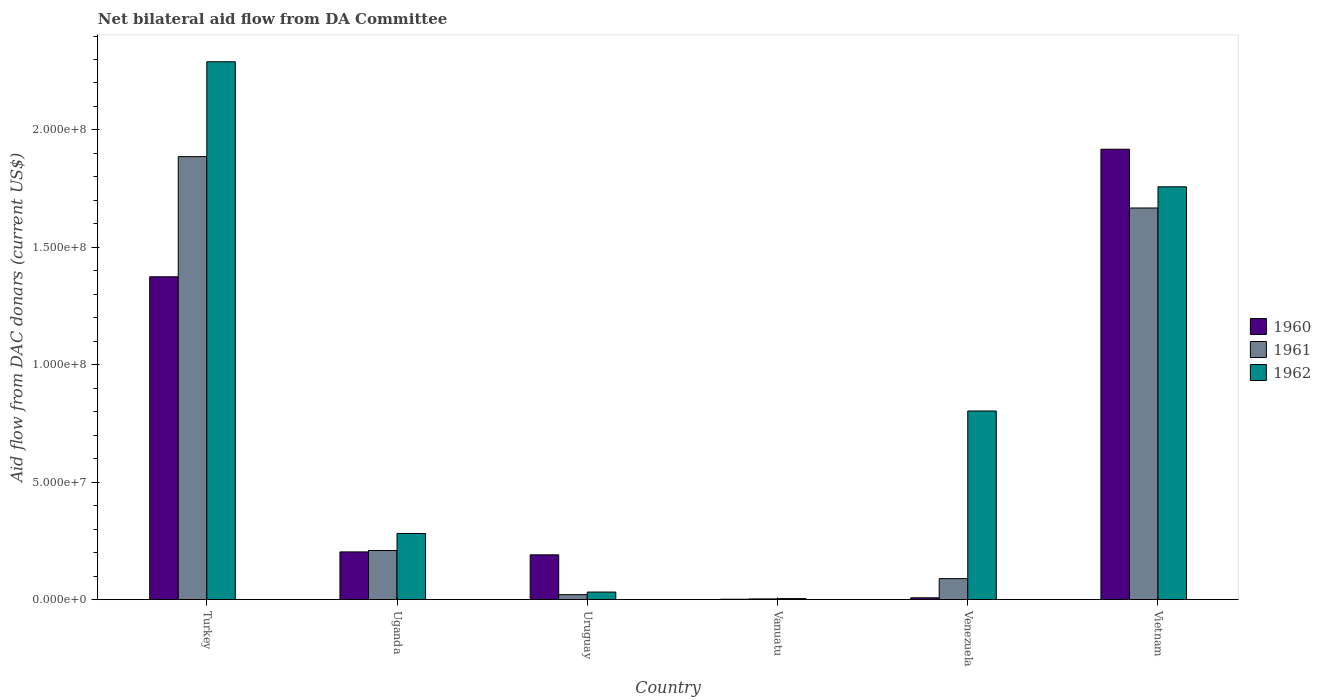How many different coloured bars are there?
Keep it short and to the point. 3. How many groups of bars are there?
Provide a short and direct response. 6. Are the number of bars on each tick of the X-axis equal?
Provide a short and direct response. Yes. How many bars are there on the 2nd tick from the right?
Your response must be concise. 3. What is the label of the 4th group of bars from the left?
Provide a short and direct response. Vanuatu. In how many cases, is the number of bars for a given country not equal to the number of legend labels?
Your answer should be compact. 0. What is the aid flow in in 1960 in Turkey?
Your answer should be very brief. 1.37e+08. Across all countries, what is the maximum aid flow in in 1960?
Give a very brief answer. 1.92e+08. Across all countries, what is the minimum aid flow in in 1960?
Offer a very short reply. 1.50e+05. In which country was the aid flow in in 1962 maximum?
Offer a terse response. Turkey. In which country was the aid flow in in 1962 minimum?
Give a very brief answer. Vanuatu. What is the total aid flow in in 1962 in the graph?
Ensure brevity in your answer.  5.17e+08. What is the difference between the aid flow in in 1961 in Turkey and that in Vanuatu?
Keep it short and to the point. 1.88e+08. What is the difference between the aid flow in in 1962 in Vietnam and the aid flow in in 1961 in Turkey?
Give a very brief answer. -1.28e+07. What is the average aid flow in in 1962 per country?
Offer a terse response. 8.61e+07. What is the difference between the aid flow in of/in 1962 and aid flow in of/in 1961 in Vietnam?
Your response must be concise. 9.02e+06. What is the ratio of the aid flow in in 1960 in Uruguay to that in Vietnam?
Your answer should be compact. 0.1. Is the aid flow in in 1962 in Turkey less than that in Uganda?
Offer a very short reply. No. Is the difference between the aid flow in in 1962 in Turkey and Vanuatu greater than the difference between the aid flow in in 1961 in Turkey and Vanuatu?
Give a very brief answer. Yes. What is the difference between the highest and the second highest aid flow in in 1961?
Provide a short and direct response. 2.19e+07. What is the difference between the highest and the lowest aid flow in in 1960?
Provide a succinct answer. 1.92e+08. What does the 2nd bar from the left in Venezuela represents?
Ensure brevity in your answer.  1961. Are all the bars in the graph horizontal?
Offer a terse response. No. How many countries are there in the graph?
Give a very brief answer. 6. Are the values on the major ticks of Y-axis written in scientific E-notation?
Your answer should be compact. Yes. How many legend labels are there?
Ensure brevity in your answer.  3. What is the title of the graph?
Give a very brief answer. Net bilateral aid flow from DA Committee. Does "2013" appear as one of the legend labels in the graph?
Offer a very short reply. No. What is the label or title of the X-axis?
Your response must be concise. Country. What is the label or title of the Y-axis?
Your answer should be very brief. Aid flow from DAC donars (current US$). What is the Aid flow from DAC donars (current US$) of 1960 in Turkey?
Make the answer very short. 1.37e+08. What is the Aid flow from DAC donars (current US$) of 1961 in Turkey?
Your response must be concise. 1.89e+08. What is the Aid flow from DAC donars (current US$) of 1962 in Turkey?
Provide a succinct answer. 2.29e+08. What is the Aid flow from DAC donars (current US$) of 1960 in Uganda?
Make the answer very short. 2.03e+07. What is the Aid flow from DAC donars (current US$) in 1961 in Uganda?
Provide a short and direct response. 2.09e+07. What is the Aid flow from DAC donars (current US$) of 1962 in Uganda?
Your answer should be very brief. 2.82e+07. What is the Aid flow from DAC donars (current US$) in 1960 in Uruguay?
Provide a succinct answer. 1.90e+07. What is the Aid flow from DAC donars (current US$) of 1961 in Uruguay?
Your answer should be very brief. 2.09e+06. What is the Aid flow from DAC donars (current US$) of 1962 in Uruguay?
Make the answer very short. 3.20e+06. What is the Aid flow from DAC donars (current US$) in 1961 in Vanuatu?
Keep it short and to the point. 2.80e+05. What is the Aid flow from DAC donars (current US$) in 1960 in Venezuela?
Your answer should be compact. 7.60e+05. What is the Aid flow from DAC donars (current US$) in 1961 in Venezuela?
Offer a terse response. 8.92e+06. What is the Aid flow from DAC donars (current US$) of 1962 in Venezuela?
Offer a very short reply. 8.03e+07. What is the Aid flow from DAC donars (current US$) in 1960 in Vietnam?
Give a very brief answer. 1.92e+08. What is the Aid flow from DAC donars (current US$) in 1961 in Vietnam?
Your answer should be compact. 1.67e+08. What is the Aid flow from DAC donars (current US$) of 1962 in Vietnam?
Provide a short and direct response. 1.76e+08. Across all countries, what is the maximum Aid flow from DAC donars (current US$) in 1960?
Your answer should be very brief. 1.92e+08. Across all countries, what is the maximum Aid flow from DAC donars (current US$) of 1961?
Provide a short and direct response. 1.89e+08. Across all countries, what is the maximum Aid flow from DAC donars (current US$) in 1962?
Your response must be concise. 2.29e+08. What is the total Aid flow from DAC donars (current US$) in 1960 in the graph?
Your answer should be compact. 3.70e+08. What is the total Aid flow from DAC donars (current US$) of 1961 in the graph?
Ensure brevity in your answer.  3.88e+08. What is the total Aid flow from DAC donars (current US$) in 1962 in the graph?
Make the answer very short. 5.17e+08. What is the difference between the Aid flow from DAC donars (current US$) of 1960 in Turkey and that in Uganda?
Your answer should be very brief. 1.17e+08. What is the difference between the Aid flow from DAC donars (current US$) of 1961 in Turkey and that in Uganda?
Your response must be concise. 1.68e+08. What is the difference between the Aid flow from DAC donars (current US$) of 1962 in Turkey and that in Uganda?
Your answer should be compact. 2.01e+08. What is the difference between the Aid flow from DAC donars (current US$) in 1960 in Turkey and that in Uruguay?
Make the answer very short. 1.18e+08. What is the difference between the Aid flow from DAC donars (current US$) of 1961 in Turkey and that in Uruguay?
Offer a very short reply. 1.87e+08. What is the difference between the Aid flow from DAC donars (current US$) in 1962 in Turkey and that in Uruguay?
Ensure brevity in your answer.  2.26e+08. What is the difference between the Aid flow from DAC donars (current US$) in 1960 in Turkey and that in Vanuatu?
Make the answer very short. 1.37e+08. What is the difference between the Aid flow from DAC donars (current US$) of 1961 in Turkey and that in Vanuatu?
Your response must be concise. 1.88e+08. What is the difference between the Aid flow from DAC donars (current US$) in 1962 in Turkey and that in Vanuatu?
Ensure brevity in your answer.  2.29e+08. What is the difference between the Aid flow from DAC donars (current US$) of 1960 in Turkey and that in Venezuela?
Ensure brevity in your answer.  1.37e+08. What is the difference between the Aid flow from DAC donars (current US$) of 1961 in Turkey and that in Venezuela?
Provide a short and direct response. 1.80e+08. What is the difference between the Aid flow from DAC donars (current US$) in 1962 in Turkey and that in Venezuela?
Your answer should be very brief. 1.49e+08. What is the difference between the Aid flow from DAC donars (current US$) in 1960 in Turkey and that in Vietnam?
Keep it short and to the point. -5.43e+07. What is the difference between the Aid flow from DAC donars (current US$) in 1961 in Turkey and that in Vietnam?
Provide a succinct answer. 2.19e+07. What is the difference between the Aid flow from DAC donars (current US$) in 1962 in Turkey and that in Vietnam?
Your answer should be compact. 5.32e+07. What is the difference between the Aid flow from DAC donars (current US$) of 1960 in Uganda and that in Uruguay?
Your answer should be very brief. 1.25e+06. What is the difference between the Aid flow from DAC donars (current US$) of 1961 in Uganda and that in Uruguay?
Keep it short and to the point. 1.88e+07. What is the difference between the Aid flow from DAC donars (current US$) in 1962 in Uganda and that in Uruguay?
Make the answer very short. 2.50e+07. What is the difference between the Aid flow from DAC donars (current US$) in 1960 in Uganda and that in Vanuatu?
Offer a very short reply. 2.02e+07. What is the difference between the Aid flow from DAC donars (current US$) of 1961 in Uganda and that in Vanuatu?
Give a very brief answer. 2.06e+07. What is the difference between the Aid flow from DAC donars (current US$) of 1962 in Uganda and that in Vanuatu?
Make the answer very short. 2.77e+07. What is the difference between the Aid flow from DAC donars (current US$) of 1960 in Uganda and that in Venezuela?
Give a very brief answer. 1.95e+07. What is the difference between the Aid flow from DAC donars (current US$) of 1961 in Uganda and that in Venezuela?
Keep it short and to the point. 1.20e+07. What is the difference between the Aid flow from DAC donars (current US$) of 1962 in Uganda and that in Venezuela?
Provide a succinct answer. -5.22e+07. What is the difference between the Aid flow from DAC donars (current US$) of 1960 in Uganda and that in Vietnam?
Offer a terse response. -1.71e+08. What is the difference between the Aid flow from DAC donars (current US$) of 1961 in Uganda and that in Vietnam?
Offer a very short reply. -1.46e+08. What is the difference between the Aid flow from DAC donars (current US$) of 1962 in Uganda and that in Vietnam?
Provide a short and direct response. -1.48e+08. What is the difference between the Aid flow from DAC donars (current US$) in 1960 in Uruguay and that in Vanuatu?
Make the answer very short. 1.89e+07. What is the difference between the Aid flow from DAC donars (current US$) in 1961 in Uruguay and that in Vanuatu?
Your answer should be compact. 1.81e+06. What is the difference between the Aid flow from DAC donars (current US$) in 1962 in Uruguay and that in Vanuatu?
Offer a terse response. 2.79e+06. What is the difference between the Aid flow from DAC donars (current US$) of 1960 in Uruguay and that in Venezuela?
Offer a terse response. 1.83e+07. What is the difference between the Aid flow from DAC donars (current US$) of 1961 in Uruguay and that in Venezuela?
Keep it short and to the point. -6.83e+06. What is the difference between the Aid flow from DAC donars (current US$) in 1962 in Uruguay and that in Venezuela?
Make the answer very short. -7.71e+07. What is the difference between the Aid flow from DAC donars (current US$) in 1960 in Uruguay and that in Vietnam?
Provide a short and direct response. -1.73e+08. What is the difference between the Aid flow from DAC donars (current US$) in 1961 in Uruguay and that in Vietnam?
Provide a short and direct response. -1.65e+08. What is the difference between the Aid flow from DAC donars (current US$) of 1962 in Uruguay and that in Vietnam?
Ensure brevity in your answer.  -1.73e+08. What is the difference between the Aid flow from DAC donars (current US$) of 1960 in Vanuatu and that in Venezuela?
Your answer should be very brief. -6.10e+05. What is the difference between the Aid flow from DAC donars (current US$) in 1961 in Vanuatu and that in Venezuela?
Your answer should be very brief. -8.64e+06. What is the difference between the Aid flow from DAC donars (current US$) in 1962 in Vanuatu and that in Venezuela?
Keep it short and to the point. -7.99e+07. What is the difference between the Aid flow from DAC donars (current US$) of 1960 in Vanuatu and that in Vietnam?
Provide a short and direct response. -1.92e+08. What is the difference between the Aid flow from DAC donars (current US$) in 1961 in Vanuatu and that in Vietnam?
Offer a very short reply. -1.66e+08. What is the difference between the Aid flow from DAC donars (current US$) in 1962 in Vanuatu and that in Vietnam?
Give a very brief answer. -1.75e+08. What is the difference between the Aid flow from DAC donars (current US$) of 1960 in Venezuela and that in Vietnam?
Offer a very short reply. -1.91e+08. What is the difference between the Aid flow from DAC donars (current US$) in 1961 in Venezuela and that in Vietnam?
Keep it short and to the point. -1.58e+08. What is the difference between the Aid flow from DAC donars (current US$) in 1962 in Venezuela and that in Vietnam?
Provide a succinct answer. -9.55e+07. What is the difference between the Aid flow from DAC donars (current US$) in 1960 in Turkey and the Aid flow from DAC donars (current US$) in 1961 in Uganda?
Provide a short and direct response. 1.17e+08. What is the difference between the Aid flow from DAC donars (current US$) in 1960 in Turkey and the Aid flow from DAC donars (current US$) in 1962 in Uganda?
Provide a short and direct response. 1.09e+08. What is the difference between the Aid flow from DAC donars (current US$) of 1961 in Turkey and the Aid flow from DAC donars (current US$) of 1962 in Uganda?
Your answer should be very brief. 1.60e+08. What is the difference between the Aid flow from DAC donars (current US$) of 1960 in Turkey and the Aid flow from DAC donars (current US$) of 1961 in Uruguay?
Keep it short and to the point. 1.35e+08. What is the difference between the Aid flow from DAC donars (current US$) of 1960 in Turkey and the Aid flow from DAC donars (current US$) of 1962 in Uruguay?
Your answer should be very brief. 1.34e+08. What is the difference between the Aid flow from DAC donars (current US$) of 1961 in Turkey and the Aid flow from DAC donars (current US$) of 1962 in Uruguay?
Make the answer very short. 1.85e+08. What is the difference between the Aid flow from DAC donars (current US$) in 1960 in Turkey and the Aid flow from DAC donars (current US$) in 1961 in Vanuatu?
Provide a succinct answer. 1.37e+08. What is the difference between the Aid flow from DAC donars (current US$) of 1960 in Turkey and the Aid flow from DAC donars (current US$) of 1962 in Vanuatu?
Provide a succinct answer. 1.37e+08. What is the difference between the Aid flow from DAC donars (current US$) in 1961 in Turkey and the Aid flow from DAC donars (current US$) in 1962 in Vanuatu?
Provide a short and direct response. 1.88e+08. What is the difference between the Aid flow from DAC donars (current US$) in 1960 in Turkey and the Aid flow from DAC donars (current US$) in 1961 in Venezuela?
Ensure brevity in your answer.  1.29e+08. What is the difference between the Aid flow from DAC donars (current US$) of 1960 in Turkey and the Aid flow from DAC donars (current US$) of 1962 in Venezuela?
Offer a very short reply. 5.72e+07. What is the difference between the Aid flow from DAC donars (current US$) in 1961 in Turkey and the Aid flow from DAC donars (current US$) in 1962 in Venezuela?
Give a very brief answer. 1.08e+08. What is the difference between the Aid flow from DAC donars (current US$) of 1960 in Turkey and the Aid flow from DAC donars (current US$) of 1961 in Vietnam?
Your answer should be very brief. -2.93e+07. What is the difference between the Aid flow from DAC donars (current US$) of 1960 in Turkey and the Aid flow from DAC donars (current US$) of 1962 in Vietnam?
Your answer should be compact. -3.83e+07. What is the difference between the Aid flow from DAC donars (current US$) in 1961 in Turkey and the Aid flow from DAC donars (current US$) in 1962 in Vietnam?
Your answer should be compact. 1.28e+07. What is the difference between the Aid flow from DAC donars (current US$) of 1960 in Uganda and the Aid flow from DAC donars (current US$) of 1961 in Uruguay?
Provide a succinct answer. 1.82e+07. What is the difference between the Aid flow from DAC donars (current US$) in 1960 in Uganda and the Aid flow from DAC donars (current US$) in 1962 in Uruguay?
Keep it short and to the point. 1.71e+07. What is the difference between the Aid flow from DAC donars (current US$) of 1961 in Uganda and the Aid flow from DAC donars (current US$) of 1962 in Uruguay?
Provide a succinct answer. 1.77e+07. What is the difference between the Aid flow from DAC donars (current US$) in 1960 in Uganda and the Aid flow from DAC donars (current US$) in 1961 in Vanuatu?
Give a very brief answer. 2.00e+07. What is the difference between the Aid flow from DAC donars (current US$) of 1960 in Uganda and the Aid flow from DAC donars (current US$) of 1962 in Vanuatu?
Offer a terse response. 1.99e+07. What is the difference between the Aid flow from DAC donars (current US$) of 1961 in Uganda and the Aid flow from DAC donars (current US$) of 1962 in Vanuatu?
Provide a short and direct response. 2.05e+07. What is the difference between the Aid flow from DAC donars (current US$) in 1960 in Uganda and the Aid flow from DAC donars (current US$) in 1961 in Venezuela?
Ensure brevity in your answer.  1.14e+07. What is the difference between the Aid flow from DAC donars (current US$) of 1960 in Uganda and the Aid flow from DAC donars (current US$) of 1962 in Venezuela?
Keep it short and to the point. -6.00e+07. What is the difference between the Aid flow from DAC donars (current US$) in 1961 in Uganda and the Aid flow from DAC donars (current US$) in 1962 in Venezuela?
Provide a short and direct response. -5.94e+07. What is the difference between the Aid flow from DAC donars (current US$) in 1960 in Uganda and the Aid flow from DAC donars (current US$) in 1961 in Vietnam?
Your answer should be very brief. -1.46e+08. What is the difference between the Aid flow from DAC donars (current US$) in 1960 in Uganda and the Aid flow from DAC donars (current US$) in 1962 in Vietnam?
Your response must be concise. -1.55e+08. What is the difference between the Aid flow from DAC donars (current US$) in 1961 in Uganda and the Aid flow from DAC donars (current US$) in 1962 in Vietnam?
Your answer should be very brief. -1.55e+08. What is the difference between the Aid flow from DAC donars (current US$) of 1960 in Uruguay and the Aid flow from DAC donars (current US$) of 1961 in Vanuatu?
Offer a very short reply. 1.88e+07. What is the difference between the Aid flow from DAC donars (current US$) in 1960 in Uruguay and the Aid flow from DAC donars (current US$) in 1962 in Vanuatu?
Give a very brief answer. 1.86e+07. What is the difference between the Aid flow from DAC donars (current US$) of 1961 in Uruguay and the Aid flow from DAC donars (current US$) of 1962 in Vanuatu?
Your answer should be very brief. 1.68e+06. What is the difference between the Aid flow from DAC donars (current US$) of 1960 in Uruguay and the Aid flow from DAC donars (current US$) of 1961 in Venezuela?
Give a very brief answer. 1.01e+07. What is the difference between the Aid flow from DAC donars (current US$) in 1960 in Uruguay and the Aid flow from DAC donars (current US$) in 1962 in Venezuela?
Ensure brevity in your answer.  -6.13e+07. What is the difference between the Aid flow from DAC donars (current US$) in 1961 in Uruguay and the Aid flow from DAC donars (current US$) in 1962 in Venezuela?
Offer a terse response. -7.82e+07. What is the difference between the Aid flow from DAC donars (current US$) in 1960 in Uruguay and the Aid flow from DAC donars (current US$) in 1961 in Vietnam?
Make the answer very short. -1.48e+08. What is the difference between the Aid flow from DAC donars (current US$) in 1960 in Uruguay and the Aid flow from DAC donars (current US$) in 1962 in Vietnam?
Keep it short and to the point. -1.57e+08. What is the difference between the Aid flow from DAC donars (current US$) of 1961 in Uruguay and the Aid flow from DAC donars (current US$) of 1962 in Vietnam?
Your answer should be very brief. -1.74e+08. What is the difference between the Aid flow from DAC donars (current US$) in 1960 in Vanuatu and the Aid flow from DAC donars (current US$) in 1961 in Venezuela?
Provide a succinct answer. -8.77e+06. What is the difference between the Aid flow from DAC donars (current US$) in 1960 in Vanuatu and the Aid flow from DAC donars (current US$) in 1962 in Venezuela?
Your answer should be compact. -8.02e+07. What is the difference between the Aid flow from DAC donars (current US$) of 1961 in Vanuatu and the Aid flow from DAC donars (current US$) of 1962 in Venezuela?
Ensure brevity in your answer.  -8.00e+07. What is the difference between the Aid flow from DAC donars (current US$) of 1960 in Vanuatu and the Aid flow from DAC donars (current US$) of 1961 in Vietnam?
Keep it short and to the point. -1.67e+08. What is the difference between the Aid flow from DAC donars (current US$) in 1960 in Vanuatu and the Aid flow from DAC donars (current US$) in 1962 in Vietnam?
Your response must be concise. -1.76e+08. What is the difference between the Aid flow from DAC donars (current US$) in 1961 in Vanuatu and the Aid flow from DAC donars (current US$) in 1962 in Vietnam?
Give a very brief answer. -1.76e+08. What is the difference between the Aid flow from DAC donars (current US$) in 1960 in Venezuela and the Aid flow from DAC donars (current US$) in 1961 in Vietnam?
Your answer should be very brief. -1.66e+08. What is the difference between the Aid flow from DAC donars (current US$) of 1960 in Venezuela and the Aid flow from DAC donars (current US$) of 1962 in Vietnam?
Offer a very short reply. -1.75e+08. What is the difference between the Aid flow from DAC donars (current US$) of 1961 in Venezuela and the Aid flow from DAC donars (current US$) of 1962 in Vietnam?
Your answer should be compact. -1.67e+08. What is the average Aid flow from DAC donars (current US$) in 1960 per country?
Provide a succinct answer. 6.16e+07. What is the average Aid flow from DAC donars (current US$) of 1961 per country?
Provide a short and direct response. 6.46e+07. What is the average Aid flow from DAC donars (current US$) of 1962 per country?
Make the answer very short. 8.61e+07. What is the difference between the Aid flow from DAC donars (current US$) of 1960 and Aid flow from DAC donars (current US$) of 1961 in Turkey?
Provide a short and direct response. -5.12e+07. What is the difference between the Aid flow from DAC donars (current US$) of 1960 and Aid flow from DAC donars (current US$) of 1962 in Turkey?
Give a very brief answer. -9.16e+07. What is the difference between the Aid flow from DAC donars (current US$) in 1961 and Aid flow from DAC donars (current US$) in 1962 in Turkey?
Your answer should be very brief. -4.04e+07. What is the difference between the Aid flow from DAC donars (current US$) in 1960 and Aid flow from DAC donars (current US$) in 1961 in Uganda?
Your answer should be compact. -6.00e+05. What is the difference between the Aid flow from DAC donars (current US$) in 1960 and Aid flow from DAC donars (current US$) in 1962 in Uganda?
Offer a very short reply. -7.85e+06. What is the difference between the Aid flow from DAC donars (current US$) in 1961 and Aid flow from DAC donars (current US$) in 1962 in Uganda?
Give a very brief answer. -7.25e+06. What is the difference between the Aid flow from DAC donars (current US$) of 1960 and Aid flow from DAC donars (current US$) of 1961 in Uruguay?
Provide a short and direct response. 1.70e+07. What is the difference between the Aid flow from DAC donars (current US$) of 1960 and Aid flow from DAC donars (current US$) of 1962 in Uruguay?
Offer a terse response. 1.58e+07. What is the difference between the Aid flow from DAC donars (current US$) of 1961 and Aid flow from DAC donars (current US$) of 1962 in Uruguay?
Your answer should be compact. -1.11e+06. What is the difference between the Aid flow from DAC donars (current US$) of 1960 and Aid flow from DAC donars (current US$) of 1961 in Vanuatu?
Keep it short and to the point. -1.30e+05. What is the difference between the Aid flow from DAC donars (current US$) in 1960 and Aid flow from DAC donars (current US$) in 1961 in Venezuela?
Provide a short and direct response. -8.16e+06. What is the difference between the Aid flow from DAC donars (current US$) in 1960 and Aid flow from DAC donars (current US$) in 1962 in Venezuela?
Offer a very short reply. -7.96e+07. What is the difference between the Aid flow from DAC donars (current US$) in 1961 and Aid flow from DAC donars (current US$) in 1962 in Venezuela?
Keep it short and to the point. -7.14e+07. What is the difference between the Aid flow from DAC donars (current US$) in 1960 and Aid flow from DAC donars (current US$) in 1961 in Vietnam?
Your answer should be very brief. 2.50e+07. What is the difference between the Aid flow from DAC donars (current US$) of 1960 and Aid flow from DAC donars (current US$) of 1962 in Vietnam?
Keep it short and to the point. 1.60e+07. What is the difference between the Aid flow from DAC donars (current US$) in 1961 and Aid flow from DAC donars (current US$) in 1962 in Vietnam?
Your response must be concise. -9.02e+06. What is the ratio of the Aid flow from DAC donars (current US$) in 1960 in Turkey to that in Uganda?
Make the answer very short. 6.77. What is the ratio of the Aid flow from DAC donars (current US$) in 1961 in Turkey to that in Uganda?
Make the answer very short. 9.03. What is the ratio of the Aid flow from DAC donars (current US$) of 1962 in Turkey to that in Uganda?
Provide a succinct answer. 8.14. What is the ratio of the Aid flow from DAC donars (current US$) of 1960 in Turkey to that in Uruguay?
Your answer should be compact. 7.22. What is the ratio of the Aid flow from DAC donars (current US$) of 1961 in Turkey to that in Uruguay?
Offer a very short reply. 90.25. What is the ratio of the Aid flow from DAC donars (current US$) of 1962 in Turkey to that in Uruguay?
Provide a short and direct response. 71.57. What is the ratio of the Aid flow from DAC donars (current US$) in 1960 in Turkey to that in Vanuatu?
Give a very brief answer. 916.4. What is the ratio of the Aid flow from DAC donars (current US$) of 1961 in Turkey to that in Vanuatu?
Provide a succinct answer. 673.68. What is the ratio of the Aid flow from DAC donars (current US$) of 1962 in Turkey to that in Vanuatu?
Give a very brief answer. 558.61. What is the ratio of the Aid flow from DAC donars (current US$) of 1960 in Turkey to that in Venezuela?
Make the answer very short. 180.87. What is the ratio of the Aid flow from DAC donars (current US$) of 1961 in Turkey to that in Venezuela?
Offer a very short reply. 21.15. What is the ratio of the Aid flow from DAC donars (current US$) of 1962 in Turkey to that in Venezuela?
Provide a short and direct response. 2.85. What is the ratio of the Aid flow from DAC donars (current US$) of 1960 in Turkey to that in Vietnam?
Keep it short and to the point. 0.72. What is the ratio of the Aid flow from DAC donars (current US$) in 1961 in Turkey to that in Vietnam?
Your response must be concise. 1.13. What is the ratio of the Aid flow from DAC donars (current US$) in 1962 in Turkey to that in Vietnam?
Provide a short and direct response. 1.3. What is the ratio of the Aid flow from DAC donars (current US$) of 1960 in Uganda to that in Uruguay?
Your answer should be very brief. 1.07. What is the ratio of the Aid flow from DAC donars (current US$) of 1962 in Uganda to that in Uruguay?
Ensure brevity in your answer.  8.8. What is the ratio of the Aid flow from DAC donars (current US$) of 1960 in Uganda to that in Vanuatu?
Give a very brief answer. 135.33. What is the ratio of the Aid flow from DAC donars (current US$) in 1961 in Uganda to that in Vanuatu?
Your response must be concise. 74.64. What is the ratio of the Aid flow from DAC donars (current US$) in 1962 in Uganda to that in Vanuatu?
Ensure brevity in your answer.  68.66. What is the ratio of the Aid flow from DAC donars (current US$) in 1960 in Uganda to that in Venezuela?
Provide a succinct answer. 26.71. What is the ratio of the Aid flow from DAC donars (current US$) in 1961 in Uganda to that in Venezuela?
Keep it short and to the point. 2.34. What is the ratio of the Aid flow from DAC donars (current US$) of 1962 in Uganda to that in Venezuela?
Your answer should be very brief. 0.35. What is the ratio of the Aid flow from DAC donars (current US$) in 1960 in Uganda to that in Vietnam?
Keep it short and to the point. 0.11. What is the ratio of the Aid flow from DAC donars (current US$) of 1961 in Uganda to that in Vietnam?
Your answer should be compact. 0.13. What is the ratio of the Aid flow from DAC donars (current US$) in 1962 in Uganda to that in Vietnam?
Provide a short and direct response. 0.16. What is the ratio of the Aid flow from DAC donars (current US$) in 1960 in Uruguay to that in Vanuatu?
Your response must be concise. 127. What is the ratio of the Aid flow from DAC donars (current US$) in 1961 in Uruguay to that in Vanuatu?
Provide a short and direct response. 7.46. What is the ratio of the Aid flow from DAC donars (current US$) of 1962 in Uruguay to that in Vanuatu?
Provide a succinct answer. 7.8. What is the ratio of the Aid flow from DAC donars (current US$) of 1960 in Uruguay to that in Venezuela?
Provide a short and direct response. 25.07. What is the ratio of the Aid flow from DAC donars (current US$) in 1961 in Uruguay to that in Venezuela?
Provide a short and direct response. 0.23. What is the ratio of the Aid flow from DAC donars (current US$) of 1962 in Uruguay to that in Venezuela?
Give a very brief answer. 0.04. What is the ratio of the Aid flow from DAC donars (current US$) of 1960 in Uruguay to that in Vietnam?
Give a very brief answer. 0.1. What is the ratio of the Aid flow from DAC donars (current US$) in 1961 in Uruguay to that in Vietnam?
Make the answer very short. 0.01. What is the ratio of the Aid flow from DAC donars (current US$) of 1962 in Uruguay to that in Vietnam?
Offer a terse response. 0.02. What is the ratio of the Aid flow from DAC donars (current US$) of 1960 in Vanuatu to that in Venezuela?
Your answer should be very brief. 0.2. What is the ratio of the Aid flow from DAC donars (current US$) in 1961 in Vanuatu to that in Venezuela?
Give a very brief answer. 0.03. What is the ratio of the Aid flow from DAC donars (current US$) in 1962 in Vanuatu to that in Venezuela?
Keep it short and to the point. 0.01. What is the ratio of the Aid flow from DAC donars (current US$) of 1960 in Vanuatu to that in Vietnam?
Provide a succinct answer. 0. What is the ratio of the Aid flow from DAC donars (current US$) in 1961 in Vanuatu to that in Vietnam?
Provide a short and direct response. 0. What is the ratio of the Aid flow from DAC donars (current US$) of 1962 in Vanuatu to that in Vietnam?
Keep it short and to the point. 0. What is the ratio of the Aid flow from DAC donars (current US$) in 1960 in Venezuela to that in Vietnam?
Make the answer very short. 0. What is the ratio of the Aid flow from DAC donars (current US$) in 1961 in Venezuela to that in Vietnam?
Make the answer very short. 0.05. What is the ratio of the Aid flow from DAC donars (current US$) of 1962 in Venezuela to that in Vietnam?
Offer a very short reply. 0.46. What is the difference between the highest and the second highest Aid flow from DAC donars (current US$) in 1960?
Ensure brevity in your answer.  5.43e+07. What is the difference between the highest and the second highest Aid flow from DAC donars (current US$) of 1961?
Keep it short and to the point. 2.19e+07. What is the difference between the highest and the second highest Aid flow from DAC donars (current US$) of 1962?
Offer a very short reply. 5.32e+07. What is the difference between the highest and the lowest Aid flow from DAC donars (current US$) of 1960?
Make the answer very short. 1.92e+08. What is the difference between the highest and the lowest Aid flow from DAC donars (current US$) of 1961?
Give a very brief answer. 1.88e+08. What is the difference between the highest and the lowest Aid flow from DAC donars (current US$) in 1962?
Provide a short and direct response. 2.29e+08. 